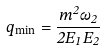Convert formula to latex. <formula><loc_0><loc_0><loc_500><loc_500>q _ { \min } = \frac { m ^ { 2 } \omega _ { 2 } } { 2 E _ { 1 } E _ { 2 } }</formula> 